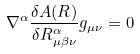Convert formula to latex. <formula><loc_0><loc_0><loc_500><loc_500>\nabla ^ { \alpha } \frac { \delta A ( R ) } { \delta R ^ { \alpha } _ { \mu \beta \nu } } g _ { \mu \nu } = 0</formula> 